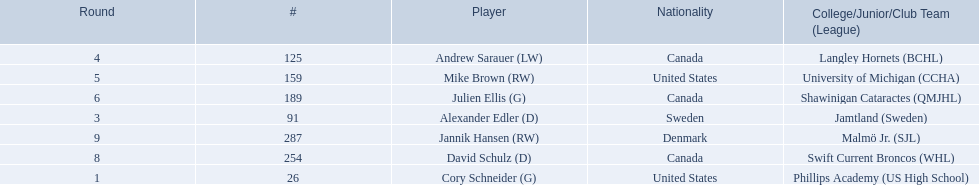Which players have canadian nationality? Andrew Sarauer (LW), Julien Ellis (G), David Schulz (D). Of those, which attended langley hornets? Andrew Sarauer (LW). 